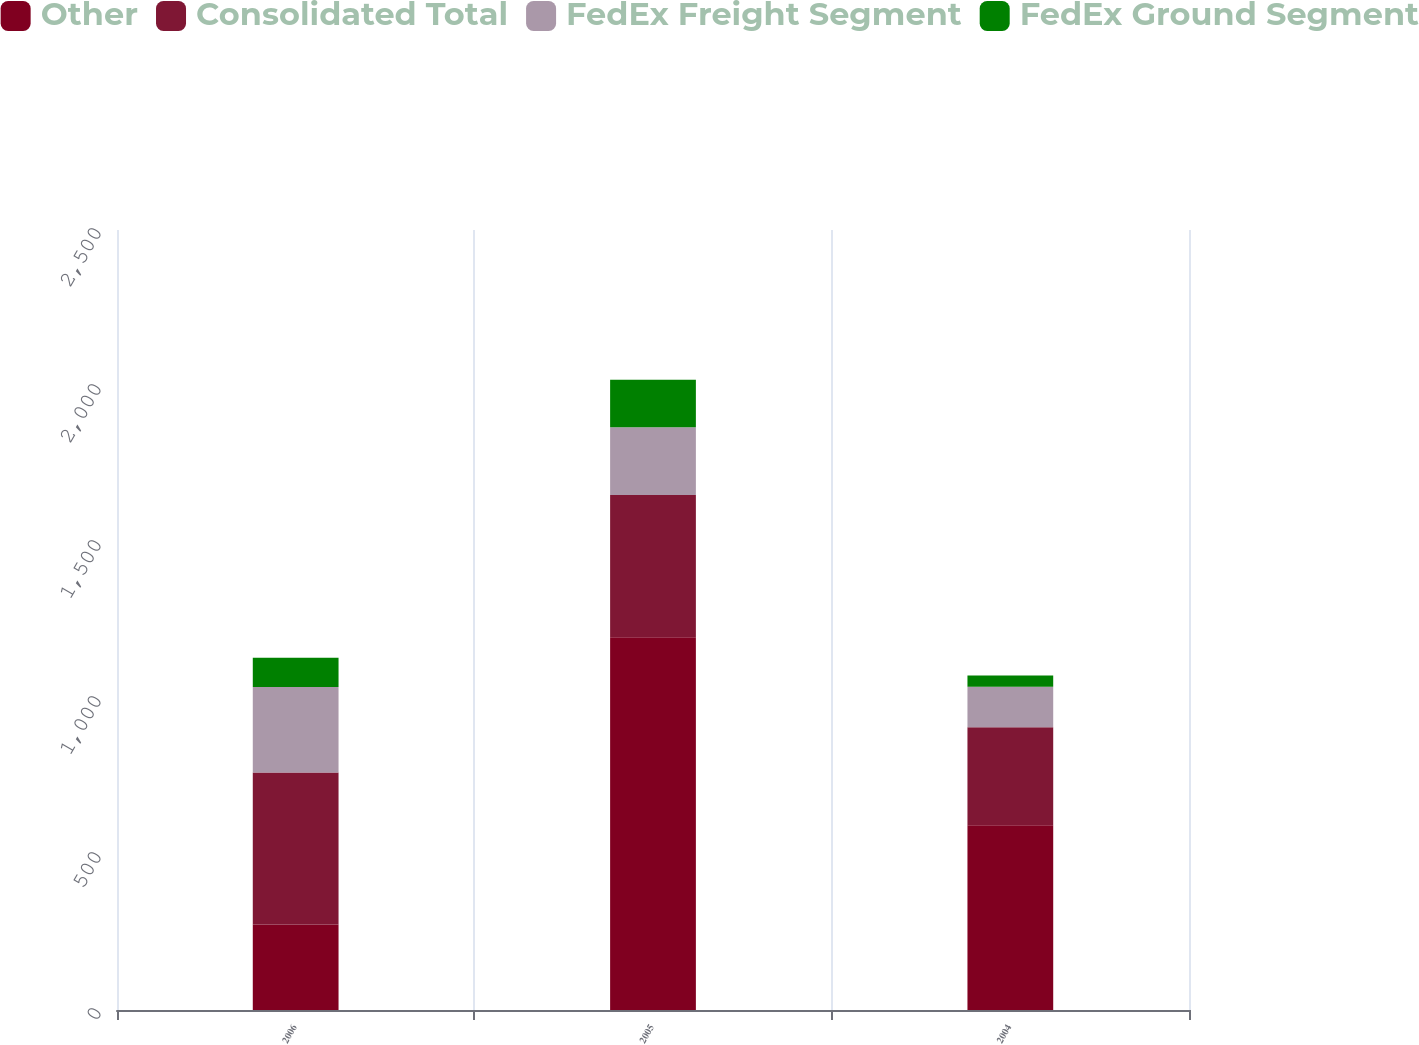Convert chart. <chart><loc_0><loc_0><loc_500><loc_500><stacked_bar_chart><ecel><fcel>2006<fcel>2005<fcel>2004<nl><fcel>Other<fcel>274<fcel>1195<fcel>592<nl><fcel>Consolidated Total<fcel>487<fcel>456<fcel>314<nl><fcel>FedEx Freight Segment<fcel>274<fcel>217<fcel>130<nl><fcel>FedEx Ground Segment<fcel>94<fcel>152<fcel>36<nl></chart> 